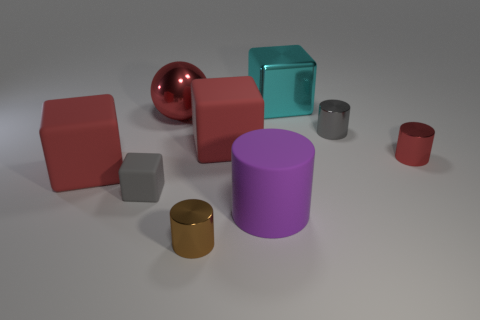What shape is the large thing that is both in front of the sphere and left of the small brown thing?
Your answer should be compact. Cube. There is a large shiny thing that is left of the metal thing in front of the metal cylinder that is right of the tiny gray shiny cylinder; what color is it?
Give a very brief answer. Red. Is the number of gray blocks that are to the right of the small gray rubber object greater than the number of tiny gray things that are to the right of the large red ball?
Your response must be concise. No. How many other objects are the same size as the brown cylinder?
Give a very brief answer. 3. What size is the cylinder that is the same color as the big ball?
Keep it short and to the point. Small. What material is the big cube that is behind the red matte object that is on the right side of the large red metallic thing?
Your answer should be very brief. Metal. There is a tiny brown object; are there any tiny brown metal objects behind it?
Offer a terse response. No. Are there more big metallic blocks on the right side of the gray shiny cylinder than small purple metal objects?
Your answer should be compact. No. Are there any rubber cubes of the same color as the large shiny block?
Keep it short and to the point. No. There is a matte cube that is the same size as the red cylinder; what is its color?
Your answer should be compact. Gray. 